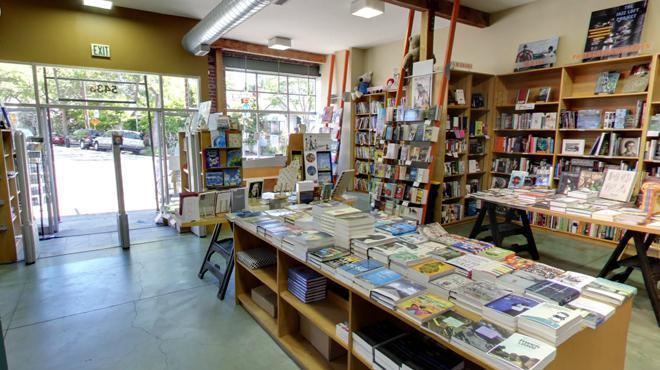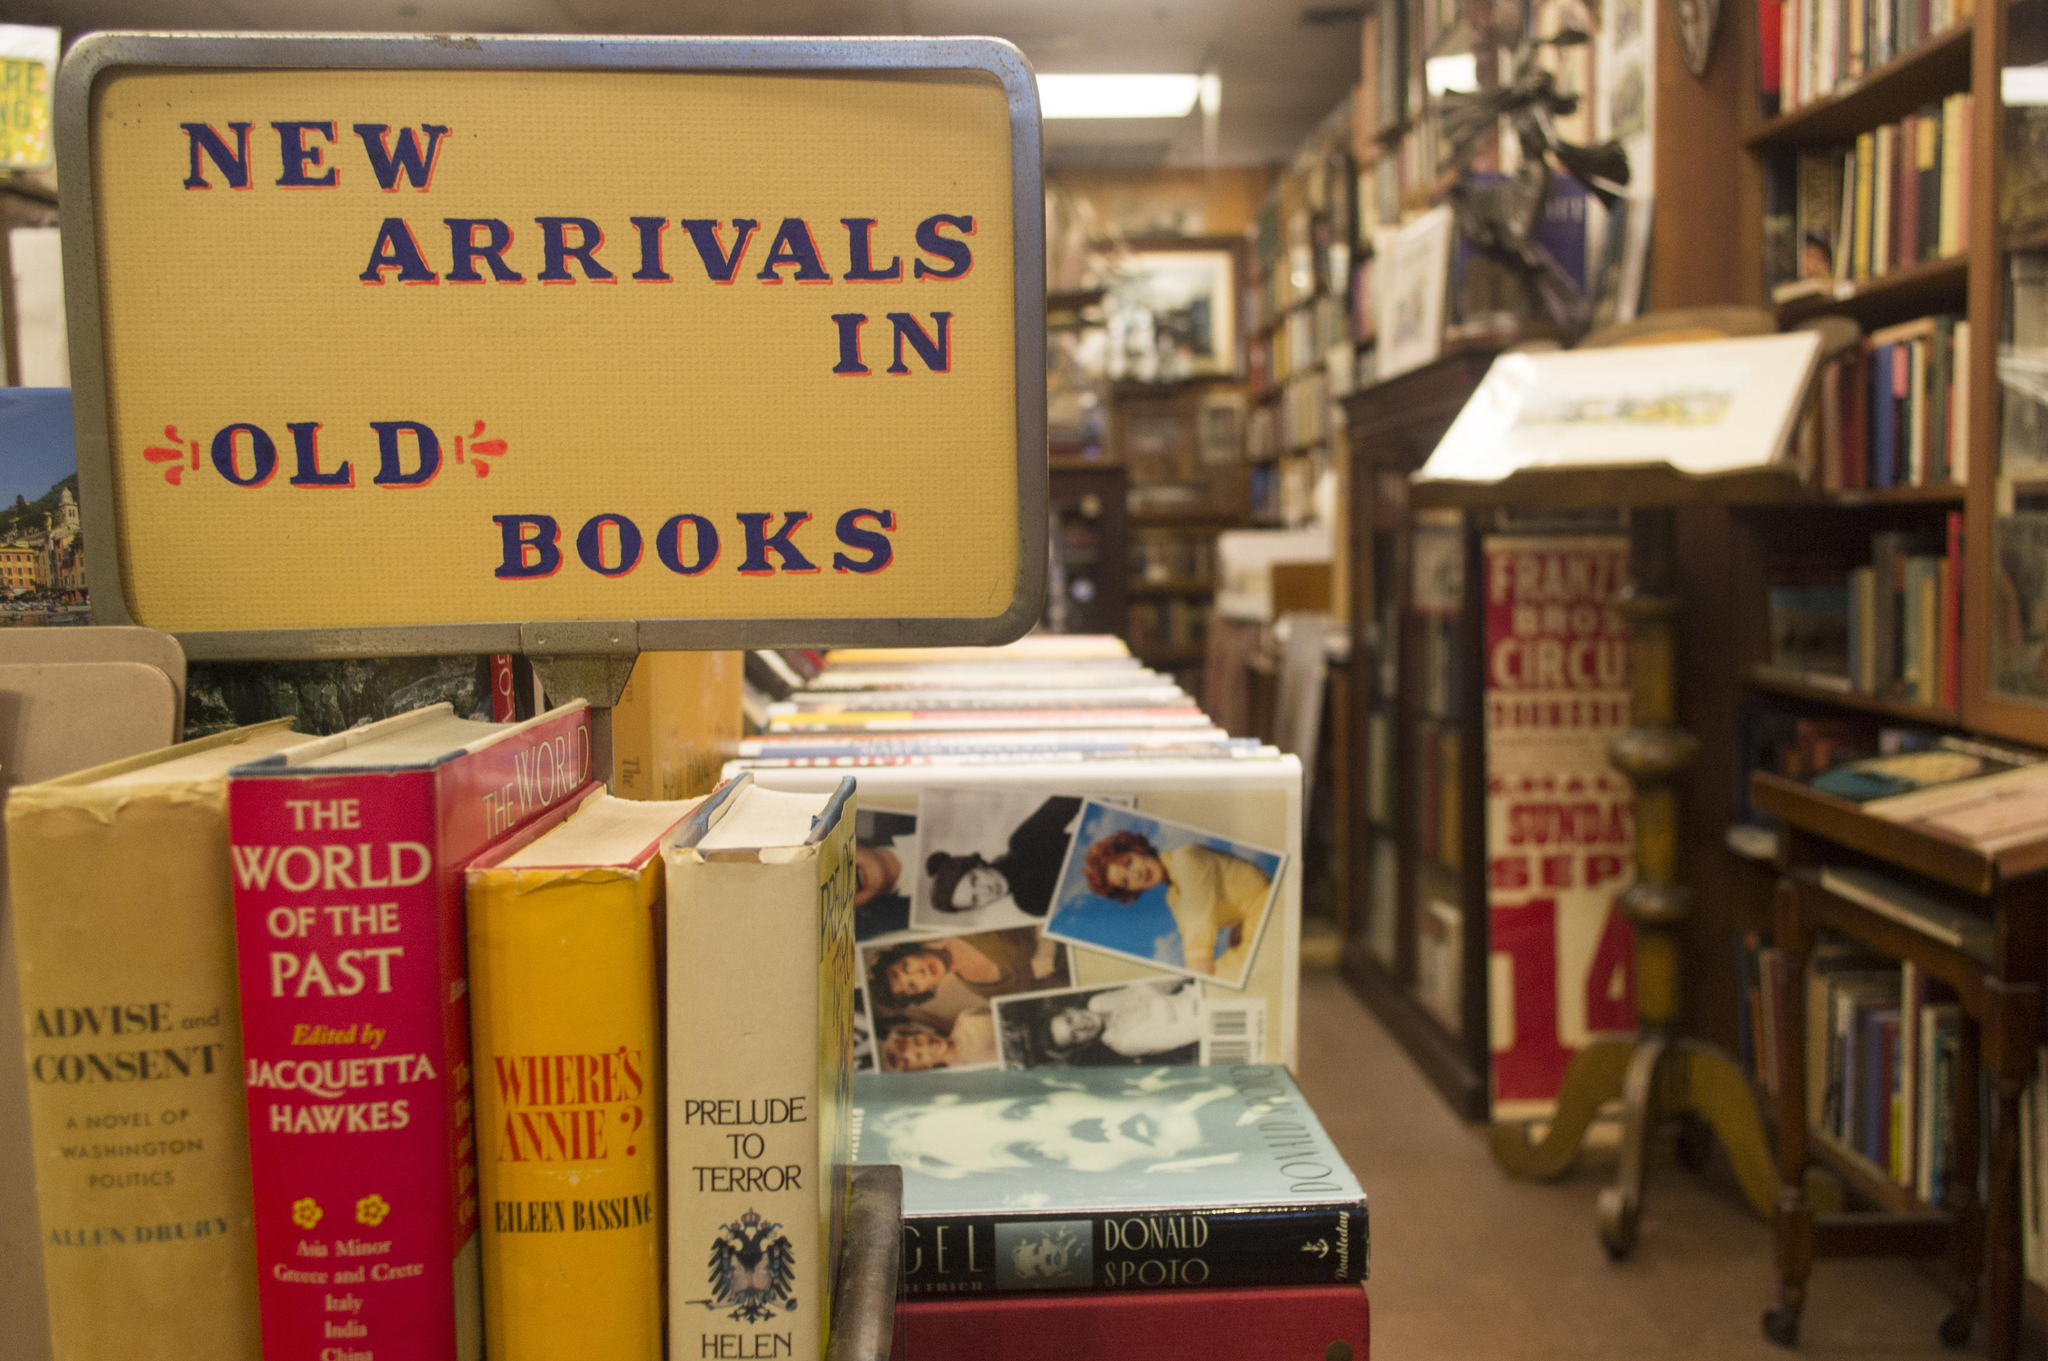The first image is the image on the left, the second image is the image on the right. Considering the images on both sides, is "A man is near some books." valid? Answer yes or no. No. 